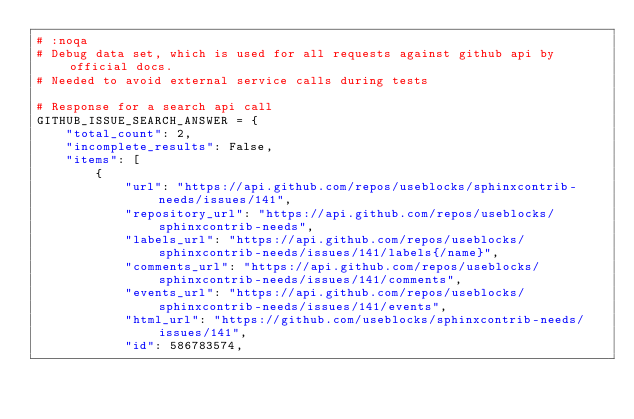<code> <loc_0><loc_0><loc_500><loc_500><_Python_># :noqa
# Debug data set, which is used for all requests against github api by official docs.
# Needed to avoid external service calls during tests

# Response for a search api call
GITHUB_ISSUE_SEARCH_ANSWER = {
    "total_count": 2,
    "incomplete_results": False,
    "items": [
        {
            "url": "https://api.github.com/repos/useblocks/sphinxcontrib-needs/issues/141",
            "repository_url": "https://api.github.com/repos/useblocks/sphinxcontrib-needs",
            "labels_url": "https://api.github.com/repos/useblocks/sphinxcontrib-needs/issues/141/labels{/name}",
            "comments_url": "https://api.github.com/repos/useblocks/sphinxcontrib-needs/issues/141/comments",
            "events_url": "https://api.github.com/repos/useblocks/sphinxcontrib-needs/issues/141/events",
            "html_url": "https://github.com/useblocks/sphinxcontrib-needs/issues/141",
            "id": 586783574,</code> 